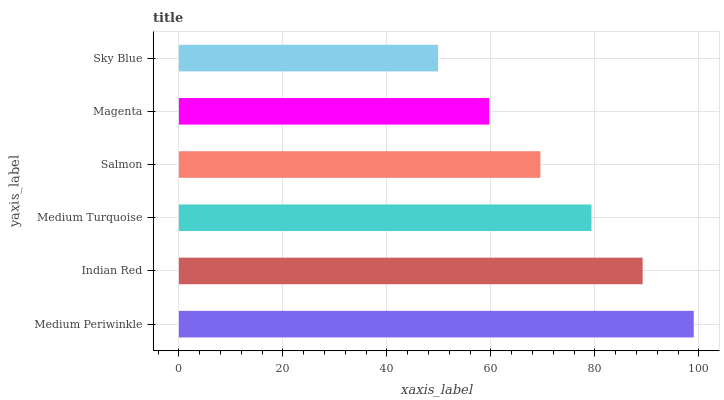Is Sky Blue the minimum?
Answer yes or no. Yes. Is Medium Periwinkle the maximum?
Answer yes or no. Yes. Is Indian Red the minimum?
Answer yes or no. No. Is Indian Red the maximum?
Answer yes or no. No. Is Medium Periwinkle greater than Indian Red?
Answer yes or no. Yes. Is Indian Red less than Medium Periwinkle?
Answer yes or no. Yes. Is Indian Red greater than Medium Periwinkle?
Answer yes or no. No. Is Medium Periwinkle less than Indian Red?
Answer yes or no. No. Is Medium Turquoise the high median?
Answer yes or no. Yes. Is Salmon the low median?
Answer yes or no. Yes. Is Sky Blue the high median?
Answer yes or no. No. Is Medium Turquoise the low median?
Answer yes or no. No. 